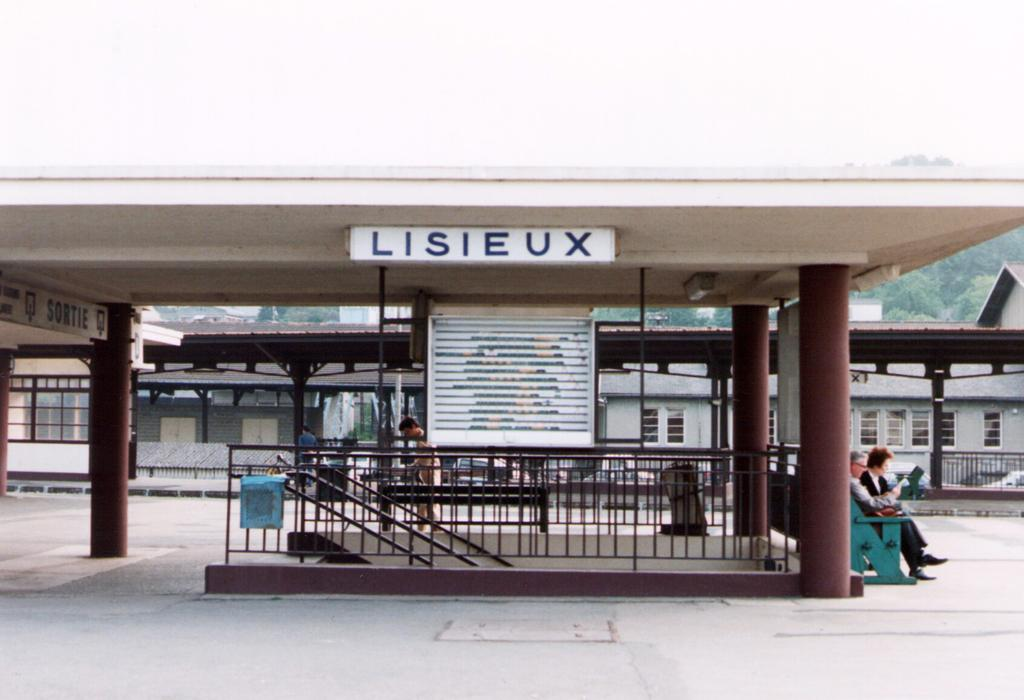What type of structures can be seen in the image? There are buildings in the image. What architectural features are present in the image? There are pillars in the image. What can be used to identify specific locations or businesses in the image? There are name boards in the image. What are the staircase holders used for in the image? The staircase holders are used to support or hold staircases in the image. Are there any people present in the image? Yes, there are people in the image. How many dogs are sitting on the staircase holders in the image? There are no dogs present in the image; only people, buildings, pillars, name boards, and staircase holders can be seen. 